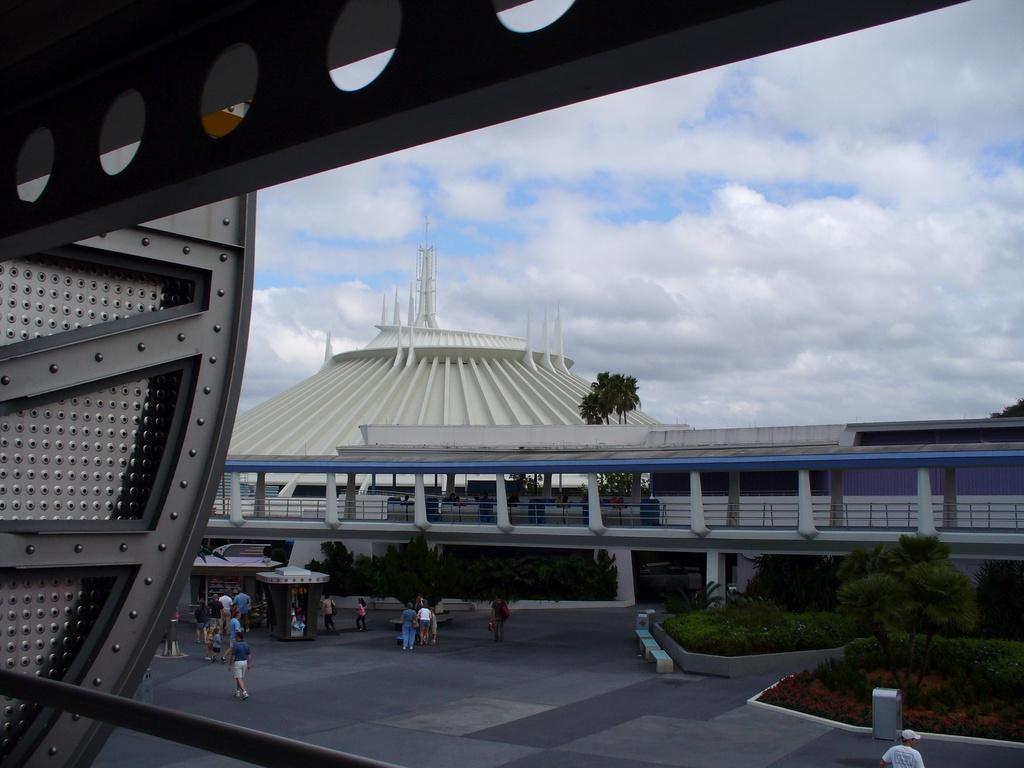In one or two sentences, can you explain what this image depicts? In this image I can see the metal object. To the side I can see the group of people with different color dresses. To the side of these people I can see the plants, many trees, bridge and the building. In the background I can see the clouds and the sky. 